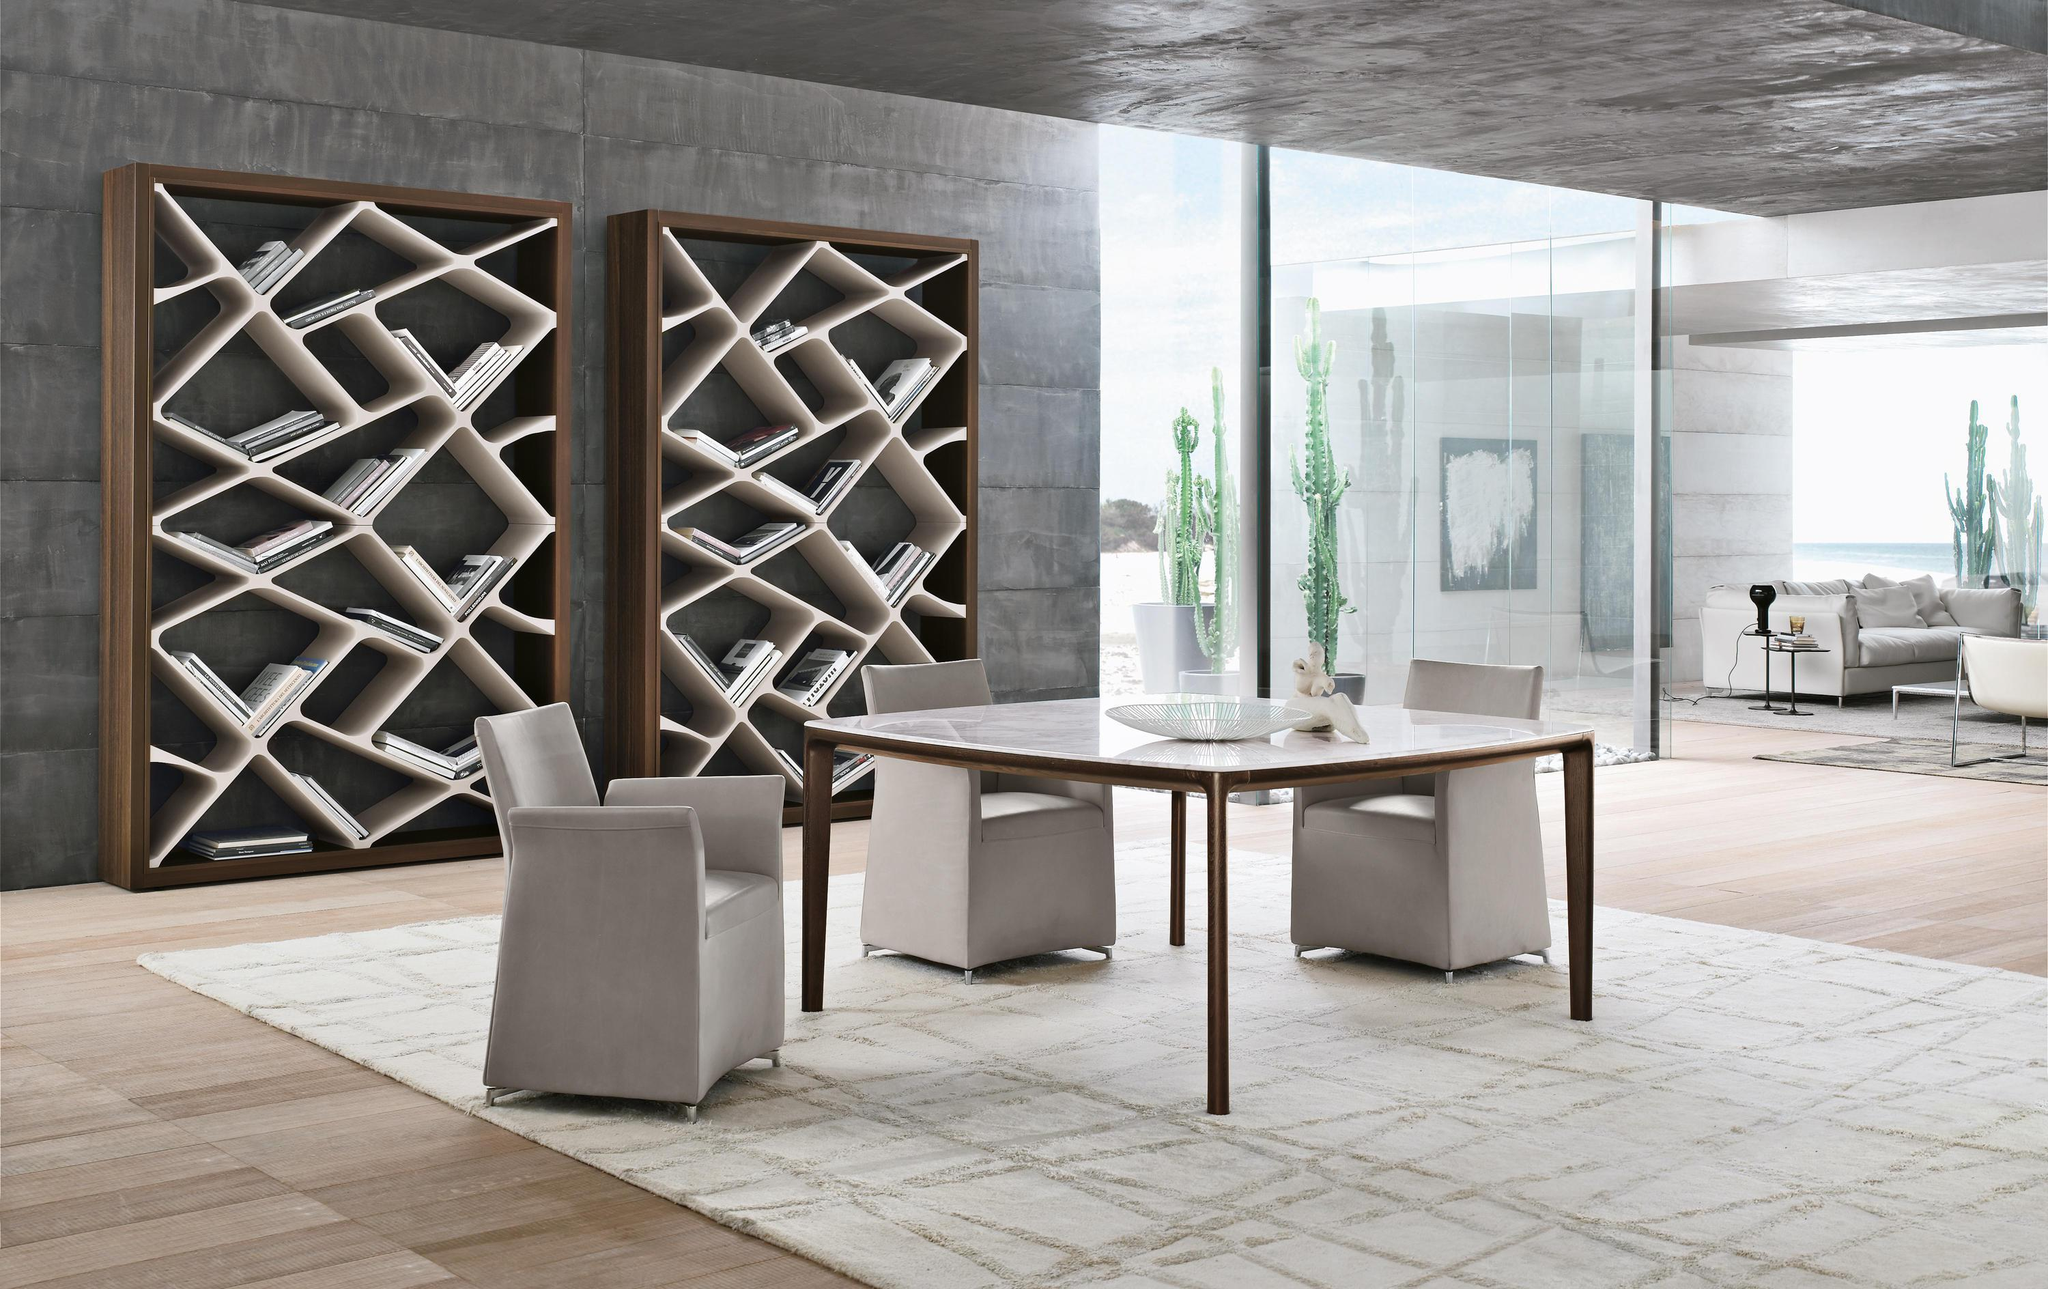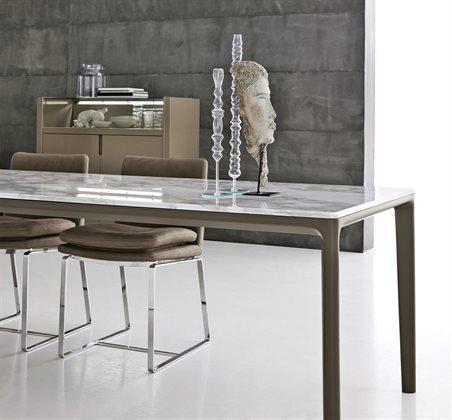The first image is the image on the left, the second image is the image on the right. For the images shown, is this caption "In one image, three armchairs are positioned by a square table." true? Answer yes or no. Yes. 